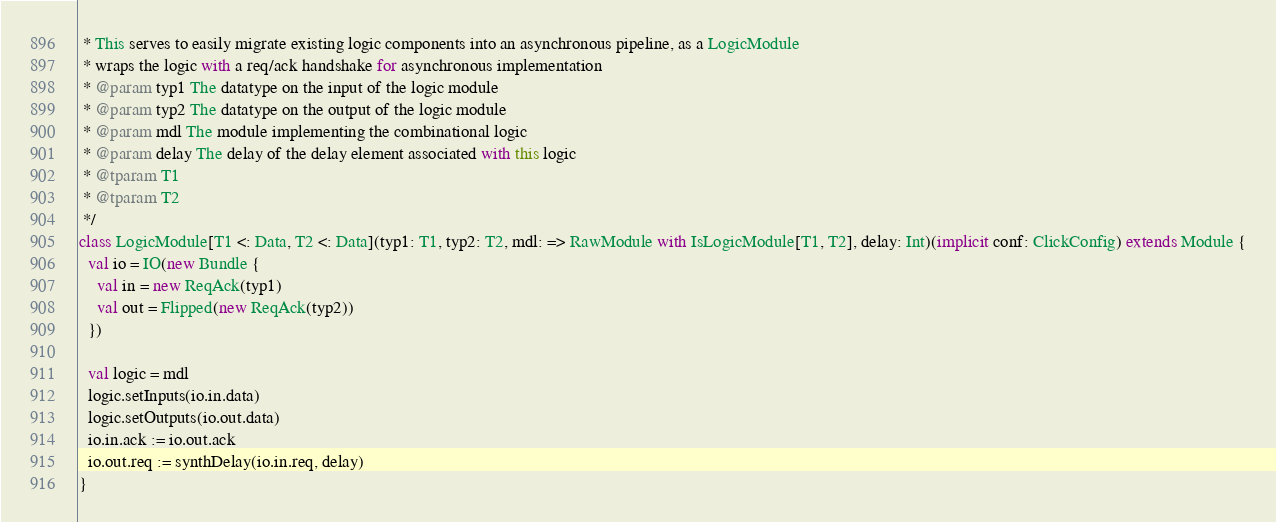Convert code to text. <code><loc_0><loc_0><loc_500><loc_500><_Scala_> * This serves to easily migrate existing logic components into an asynchronous pipeline, as a LogicModule
 * wraps the logic with a req/ack handshake for asynchronous implementation
 * @param typ1 The datatype on the input of the logic module
 * @param typ2 The datatype on the output of the logic module
 * @param mdl The module implementing the combinational logic
 * @param delay The delay of the delay element associated with this logic
 * @tparam T1
 * @tparam T2
 */
class LogicModule[T1 <: Data, T2 <: Data](typ1: T1, typ2: T2, mdl: => RawModule with IsLogicModule[T1, T2], delay: Int)(implicit conf: ClickConfig) extends Module {
  val io = IO(new Bundle {
    val in = new ReqAck(typ1)
    val out = Flipped(new ReqAck(typ2))
  })

  val logic = mdl
  logic.setInputs(io.in.data)
  logic.setOutputs(io.out.data)
  io.in.ack := io.out.ack
  io.out.req := synthDelay(io.in.req, delay)
}
</code> 